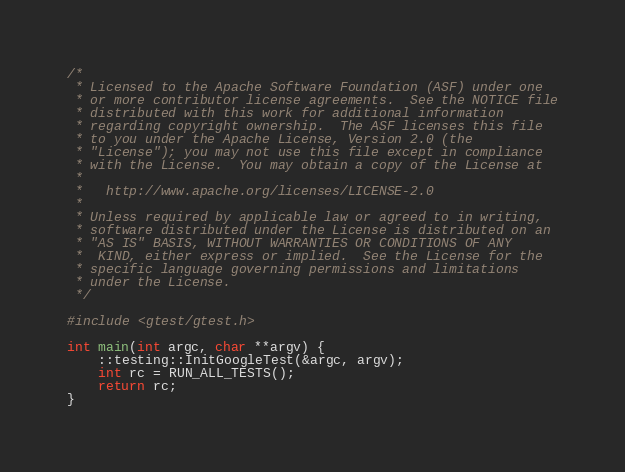Convert code to text. <code><loc_0><loc_0><loc_500><loc_500><_C++_>/*
 * Licensed to the Apache Software Foundation (ASF) under one
 * or more contributor license agreements.  See the NOTICE file
 * distributed with this work for additional information
 * regarding copyright ownership.  The ASF licenses this file
 * to you under the Apache License, Version 2.0 (the
 * "License"); you may not use this file except in compliance
 * with the License.  You may obtain a copy of the License at
 *
 *   http://www.apache.org/licenses/LICENSE-2.0
 *
 * Unless required by applicable law or agreed to in writing,
 * software distributed under the License is distributed on an
 * "AS IS" BASIS, WITHOUT WARRANTIES OR CONDITIONS OF ANY
 *  KIND, either express or implied.  See the License for the
 * specific language governing permissions and limitations
 * under the License.
 */

#include <gtest/gtest.h>

int main(int argc, char **argv) {
    ::testing::InitGoogleTest(&argc, argv);
    int rc = RUN_ALL_TESTS();
    return rc;
}</code> 